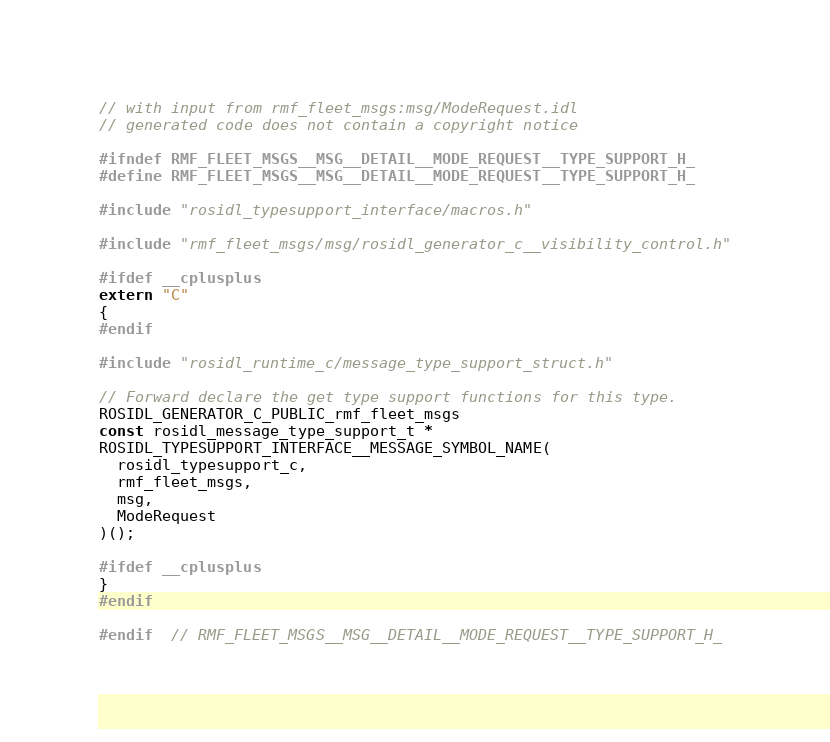Convert code to text. <code><loc_0><loc_0><loc_500><loc_500><_C_>// with input from rmf_fleet_msgs:msg/ModeRequest.idl
// generated code does not contain a copyright notice

#ifndef RMF_FLEET_MSGS__MSG__DETAIL__MODE_REQUEST__TYPE_SUPPORT_H_
#define RMF_FLEET_MSGS__MSG__DETAIL__MODE_REQUEST__TYPE_SUPPORT_H_

#include "rosidl_typesupport_interface/macros.h"

#include "rmf_fleet_msgs/msg/rosidl_generator_c__visibility_control.h"

#ifdef __cplusplus
extern "C"
{
#endif

#include "rosidl_runtime_c/message_type_support_struct.h"

// Forward declare the get type support functions for this type.
ROSIDL_GENERATOR_C_PUBLIC_rmf_fleet_msgs
const rosidl_message_type_support_t *
ROSIDL_TYPESUPPORT_INTERFACE__MESSAGE_SYMBOL_NAME(
  rosidl_typesupport_c,
  rmf_fleet_msgs,
  msg,
  ModeRequest
)();

#ifdef __cplusplus
}
#endif

#endif  // RMF_FLEET_MSGS__MSG__DETAIL__MODE_REQUEST__TYPE_SUPPORT_H_
</code> 